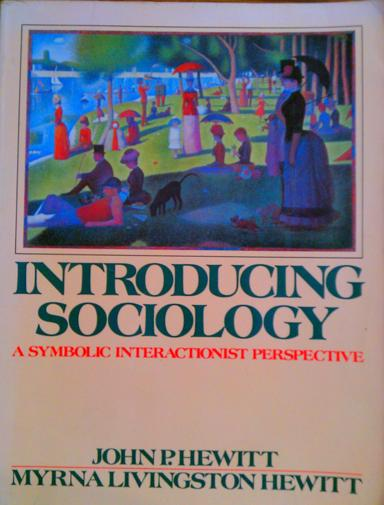How does the use of vibrant colors on the book's cover influence the perception of the content? The vibrant colors used on the book cover are likely intended to draw attention to the dynamic and multifaceted nature of human society. Bright colors often evoke feelings of energy and vivacity, which may suggest that the study of sociology—particularly through the symbolic interactionist perspective—is an engaging and lively subject. This artistic choice can be seen as a visual metaphor for the rich tapestry of human interactions that form the essence of sociological inquiry. 